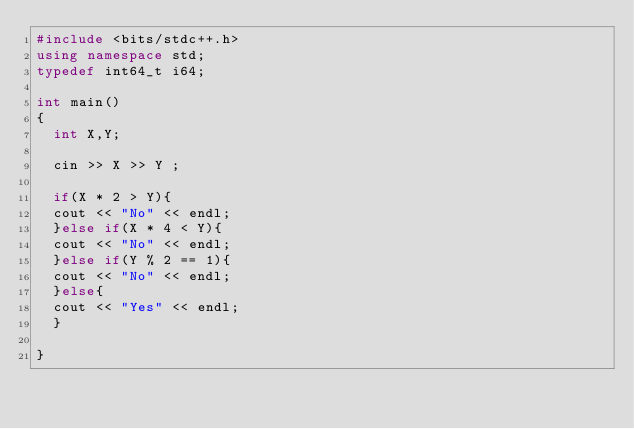Convert code to text. <code><loc_0><loc_0><loc_500><loc_500><_C++_>#include <bits/stdc++.h>
using namespace std;
typedef int64_t i64;

int main()
{
  int X,Y;

  cin >> X >> Y ;
  
  if(X * 2 > Y){
  cout << "No" << endl;
  }else if(X * 4 < Y){
  cout << "No" << endl;
  }else if(Y % 2 == 1){
  cout << "No" << endl;
  }else{
  cout << "Yes" << endl;
  }
 
}
</code> 